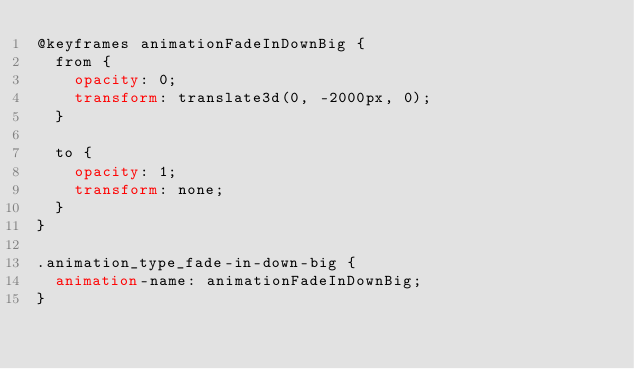<code> <loc_0><loc_0><loc_500><loc_500><_CSS_>@keyframes animationFadeInDownBig {
  from {
    opacity: 0;
    transform: translate3d(0, -2000px, 0);
  }

  to {
    opacity: 1;
    transform: none;
  }
}

.animation_type_fade-in-down-big {
  animation-name: animationFadeInDownBig;
}
</code> 